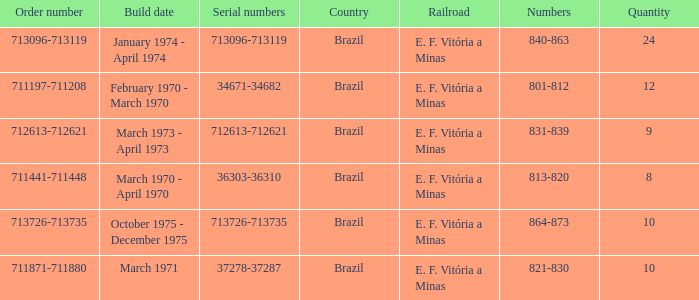The order number 713726-713735 has what serial number? 713726-713735. 